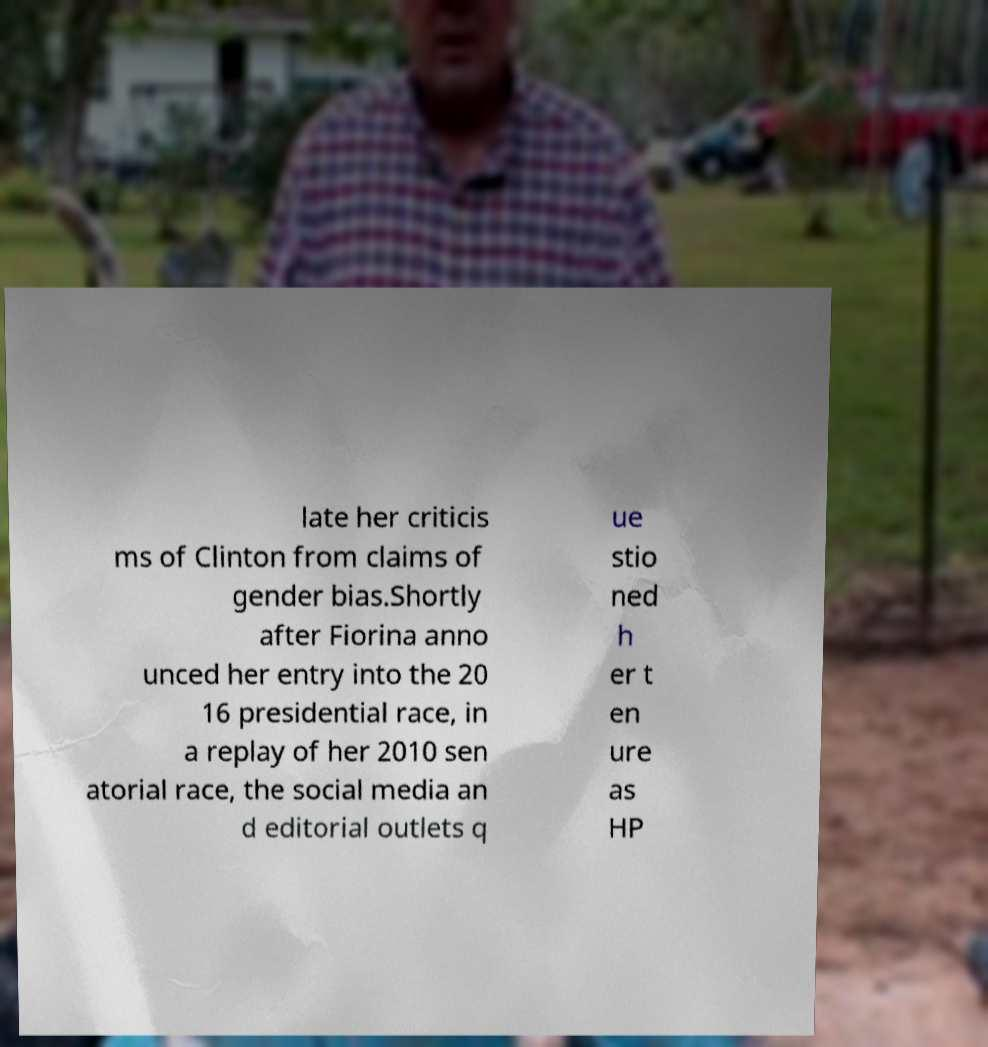There's text embedded in this image that I need extracted. Can you transcribe it verbatim? late her criticis ms of Clinton from claims of gender bias.Shortly after Fiorina anno unced her entry into the 20 16 presidential race, in a replay of her 2010 sen atorial race, the social media an d editorial outlets q ue stio ned h er t en ure as HP 